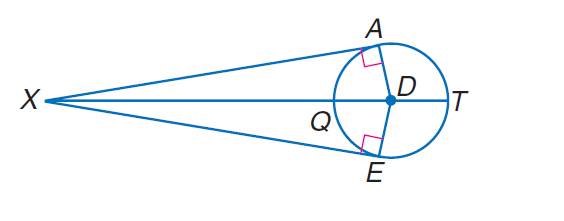Answer the mathemtical geometry problem and directly provide the correct option letter.
Question: Find A X if E X = 24 and D E = 7.
Choices: A: 1 B: 7 C: 24 D: 25 C 